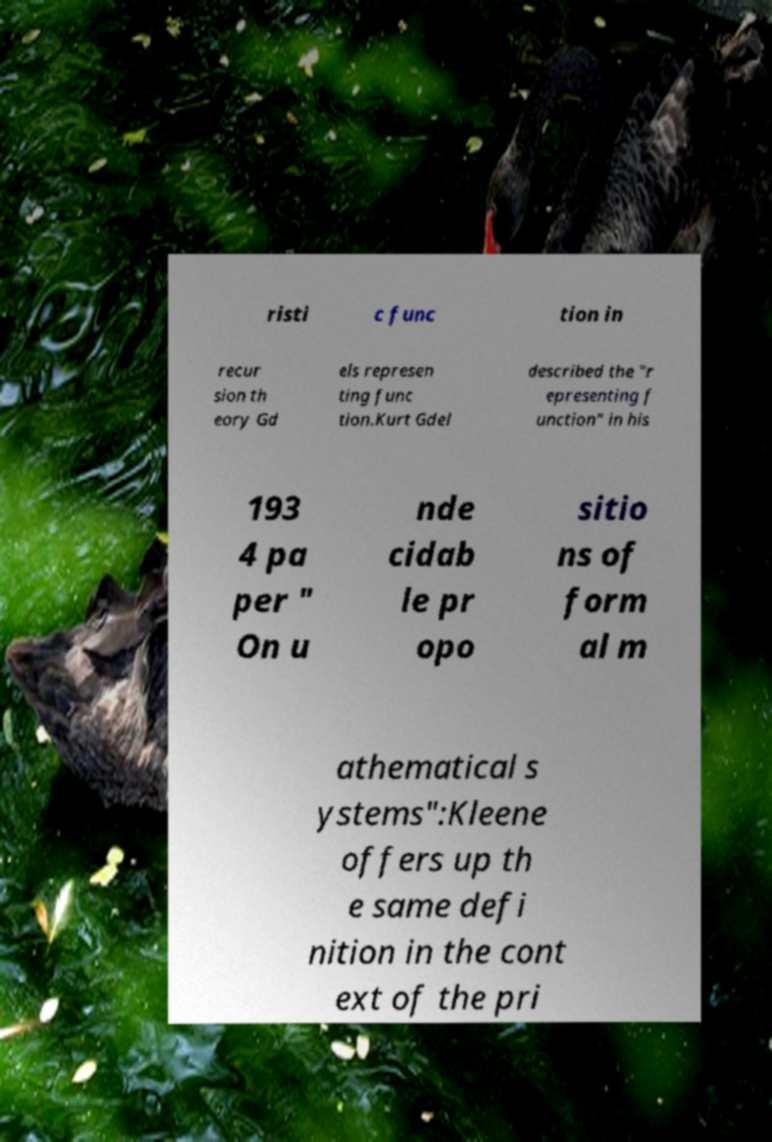Can you read and provide the text displayed in the image?This photo seems to have some interesting text. Can you extract and type it out for me? risti c func tion in recur sion th eory Gd els represen ting func tion.Kurt Gdel described the "r epresenting f unction" in his 193 4 pa per " On u nde cidab le pr opo sitio ns of form al m athematical s ystems":Kleene offers up th e same defi nition in the cont ext of the pri 